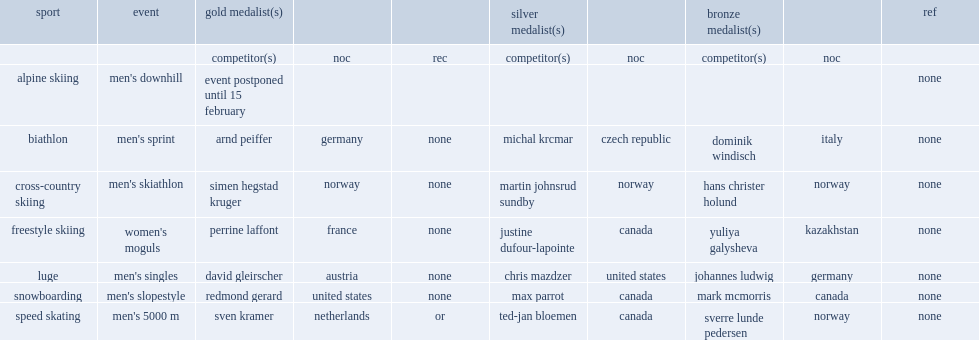Who won the gold in the snowboarding in the men's slopestyle? Redmond gerard. 